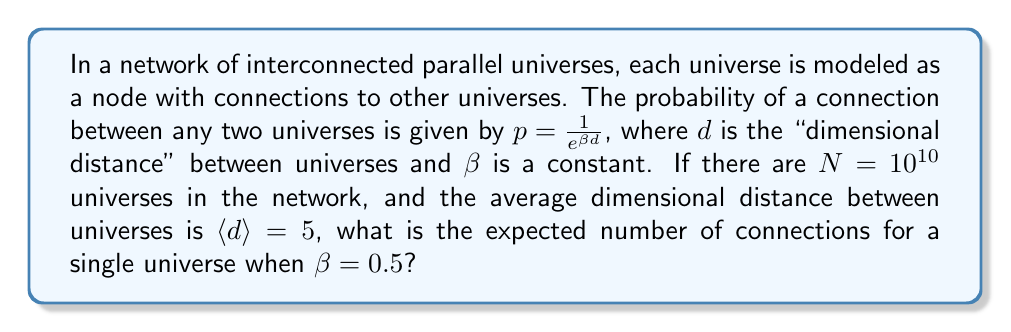What is the answer to this math problem? To solve this problem, we'll follow these steps:

1) The probability of a connection between two universes is given by:

   $$p = \frac{1}{e^{\beta d}}$$

2) We're given that $\beta = 0.5$ and the average dimensional distance $\langle d \rangle = 5$. Let's calculate the average probability of a connection:

   $$\langle p \rangle = \frac{1}{e^{\beta \langle d \rangle}} = \frac{1}{e^{0.5 \cdot 5}} = \frac{1}{e^{2.5}} \approx 0.0821$$

3) In a network with $N$ universes, each universe can potentially connect to $N-1$ other universes. The expected number of connections for a single universe is thus:

   $$E(\text{connections}) = (N-1) \cdot \langle p \rangle$$

4) Substituting the values:

   $$E(\text{connections}) = (10^{10} - 1) \cdot 0.0821 \approx 8.21 \times 10^8$$

5) Therefore, the expected number of connections for a single universe is approximately 821 million.
Answer: $8.21 \times 10^8$ 